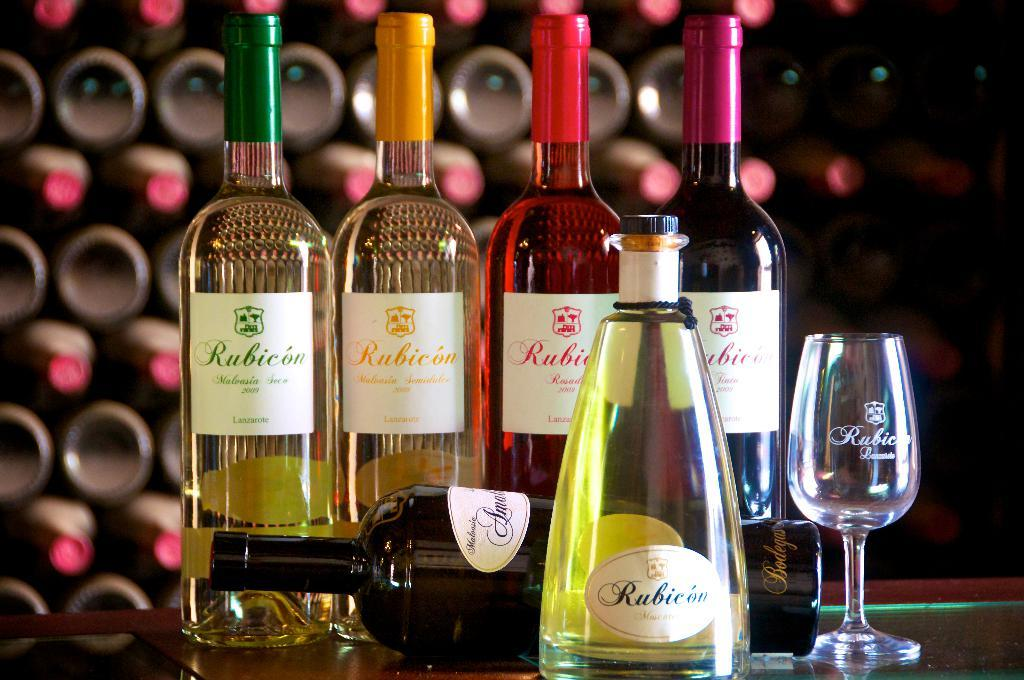What type of objects can be seen on the table in the image? There are multiple bottles and a wine glass on the table in the image. Is there any indication of a specific event or occasion in the image? The presence of multiple bottles and a wine glass might suggest a gathering or celebration, but the image itself does not provide any explicit context. What is the condition of one of the bottles in the image? One bottle is fallen in the image. What is visible in the background of the image? There is a wall in the background of the image. What type of cover is protecting the bee in the image? There is no bee present in the image, so there is no cover protecting it. 